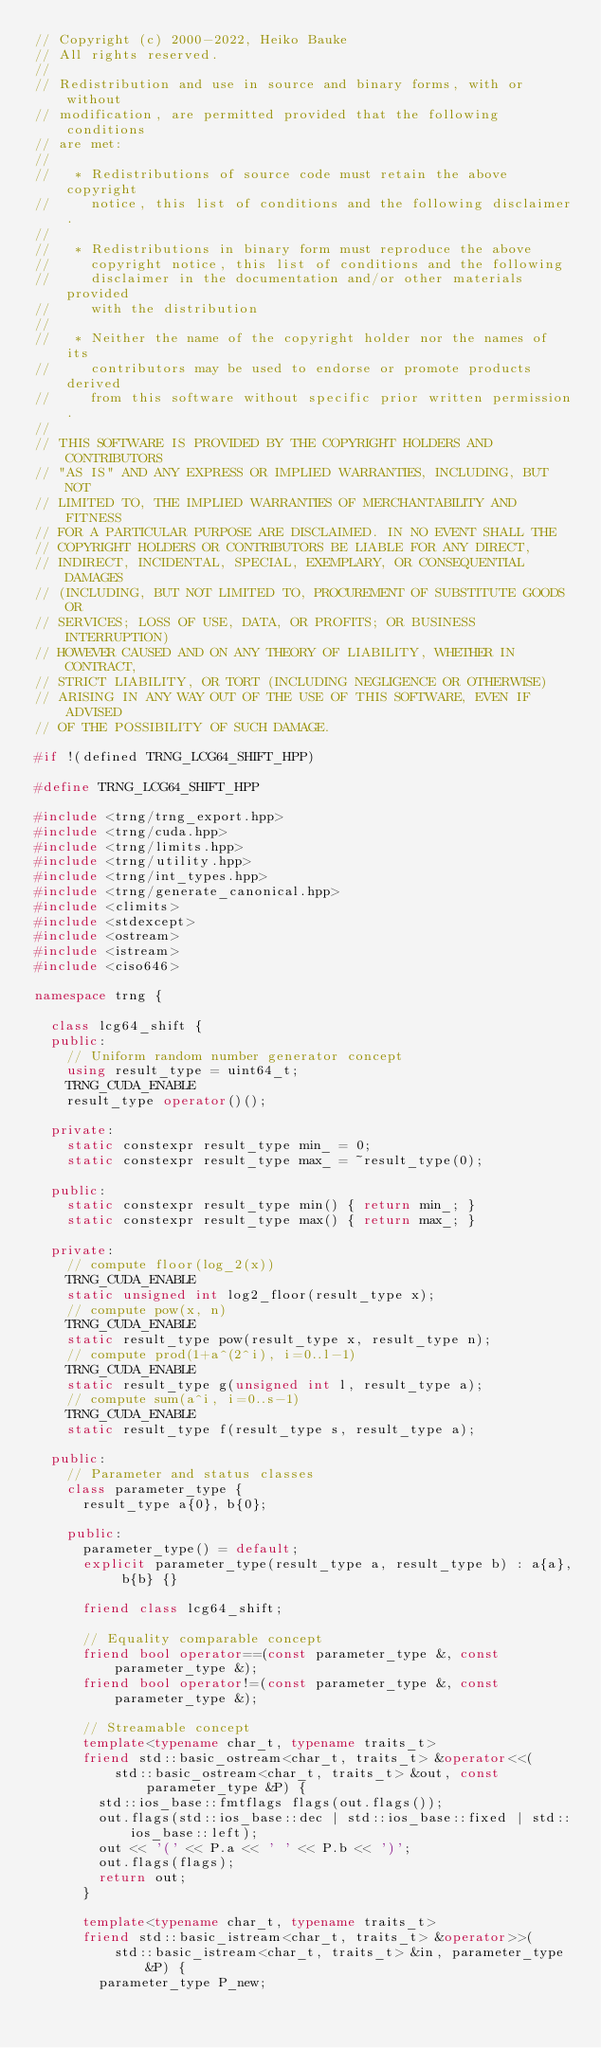Convert code to text. <code><loc_0><loc_0><loc_500><loc_500><_C++_>// Copyright (c) 2000-2022, Heiko Bauke
// All rights reserved.
//
// Redistribution and use in source and binary forms, with or without
// modification, are permitted provided that the following conditions
// are met:
//
//   * Redistributions of source code must retain the above copyright
//     notice, this list of conditions and the following disclaimer.
//
//   * Redistributions in binary form must reproduce the above
//     copyright notice, this list of conditions and the following
//     disclaimer in the documentation and/or other materials provided
//     with the distribution
//
//   * Neither the name of the copyright holder nor the names of its
//     contributors may be used to endorse or promote products derived
//     from this software without specific prior written permission.
//
// THIS SOFTWARE IS PROVIDED BY THE COPYRIGHT HOLDERS AND CONTRIBUTORS
// "AS IS" AND ANY EXPRESS OR IMPLIED WARRANTIES, INCLUDING, BUT NOT
// LIMITED TO, THE IMPLIED WARRANTIES OF MERCHANTABILITY AND FITNESS
// FOR A PARTICULAR PURPOSE ARE DISCLAIMED. IN NO EVENT SHALL THE
// COPYRIGHT HOLDERS OR CONTRIBUTORS BE LIABLE FOR ANY DIRECT,
// INDIRECT, INCIDENTAL, SPECIAL, EXEMPLARY, OR CONSEQUENTIAL DAMAGES
// (INCLUDING, BUT NOT LIMITED TO, PROCUREMENT OF SUBSTITUTE GOODS OR
// SERVICES; LOSS OF USE, DATA, OR PROFITS; OR BUSINESS INTERRUPTION)
// HOWEVER CAUSED AND ON ANY THEORY OF LIABILITY, WHETHER IN CONTRACT,
// STRICT LIABILITY, OR TORT (INCLUDING NEGLIGENCE OR OTHERWISE)
// ARISING IN ANY WAY OUT OF THE USE OF THIS SOFTWARE, EVEN IF ADVISED
// OF THE POSSIBILITY OF SUCH DAMAGE.

#if !(defined TRNG_LCG64_SHIFT_HPP)

#define TRNG_LCG64_SHIFT_HPP

#include <trng/trng_export.hpp>
#include <trng/cuda.hpp>
#include <trng/limits.hpp>
#include <trng/utility.hpp>
#include <trng/int_types.hpp>
#include <trng/generate_canonical.hpp>
#include <climits>
#include <stdexcept>
#include <ostream>
#include <istream>
#include <ciso646>

namespace trng {

  class lcg64_shift {
  public:
    // Uniform random number generator concept
    using result_type = uint64_t;
    TRNG_CUDA_ENABLE
    result_type operator()();

  private:
    static constexpr result_type min_ = 0;
    static constexpr result_type max_ = ~result_type(0);

  public:
    static constexpr result_type min() { return min_; }
    static constexpr result_type max() { return max_; }

  private:
    // compute floor(log_2(x))
    TRNG_CUDA_ENABLE
    static unsigned int log2_floor(result_type x);
    // compute pow(x, n)
    TRNG_CUDA_ENABLE
    static result_type pow(result_type x, result_type n);
    // compute prod(1+a^(2^i), i=0..l-1)
    TRNG_CUDA_ENABLE
    static result_type g(unsigned int l, result_type a);
    // compute sum(a^i, i=0..s-1)
    TRNG_CUDA_ENABLE
    static result_type f(result_type s, result_type a);

  public:
    // Parameter and status classes
    class parameter_type {
      result_type a{0}, b{0};

    public:
      parameter_type() = default;
      explicit parameter_type(result_type a, result_type b) : a{a}, b{b} {}

      friend class lcg64_shift;

      // Equality comparable concept
      friend bool operator==(const parameter_type &, const parameter_type &);
      friend bool operator!=(const parameter_type &, const parameter_type &);

      // Streamable concept
      template<typename char_t, typename traits_t>
      friend std::basic_ostream<char_t, traits_t> &operator<<(
          std::basic_ostream<char_t, traits_t> &out, const parameter_type &P) {
        std::ios_base::fmtflags flags(out.flags());
        out.flags(std::ios_base::dec | std::ios_base::fixed | std::ios_base::left);
        out << '(' << P.a << ' ' << P.b << ')';
        out.flags(flags);
        return out;
      }

      template<typename char_t, typename traits_t>
      friend std::basic_istream<char_t, traits_t> &operator>>(
          std::basic_istream<char_t, traits_t> &in, parameter_type &P) {
        parameter_type P_new;</code> 